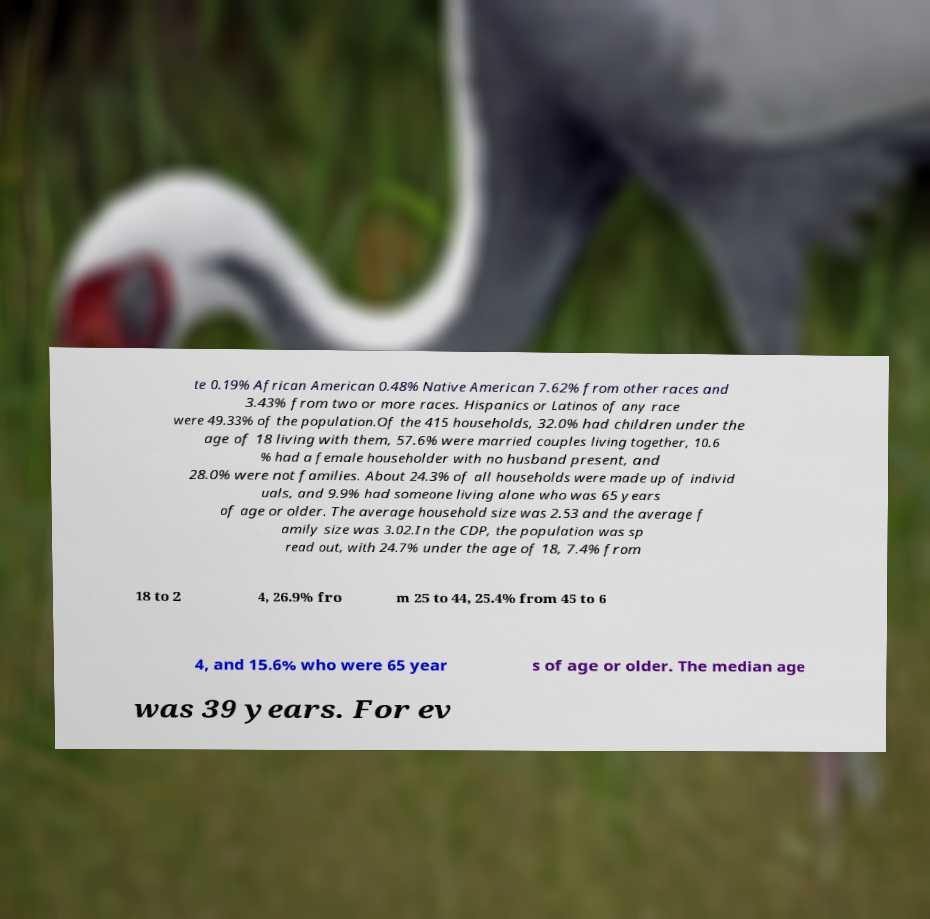There's text embedded in this image that I need extracted. Can you transcribe it verbatim? te 0.19% African American 0.48% Native American 7.62% from other races and 3.43% from two or more races. Hispanics or Latinos of any race were 49.33% of the population.Of the 415 households, 32.0% had children under the age of 18 living with them, 57.6% were married couples living together, 10.6 % had a female householder with no husband present, and 28.0% were not families. About 24.3% of all households were made up of individ uals, and 9.9% had someone living alone who was 65 years of age or older. The average household size was 2.53 and the average f amily size was 3.02.In the CDP, the population was sp read out, with 24.7% under the age of 18, 7.4% from 18 to 2 4, 26.9% fro m 25 to 44, 25.4% from 45 to 6 4, and 15.6% who were 65 year s of age or older. The median age was 39 years. For ev 